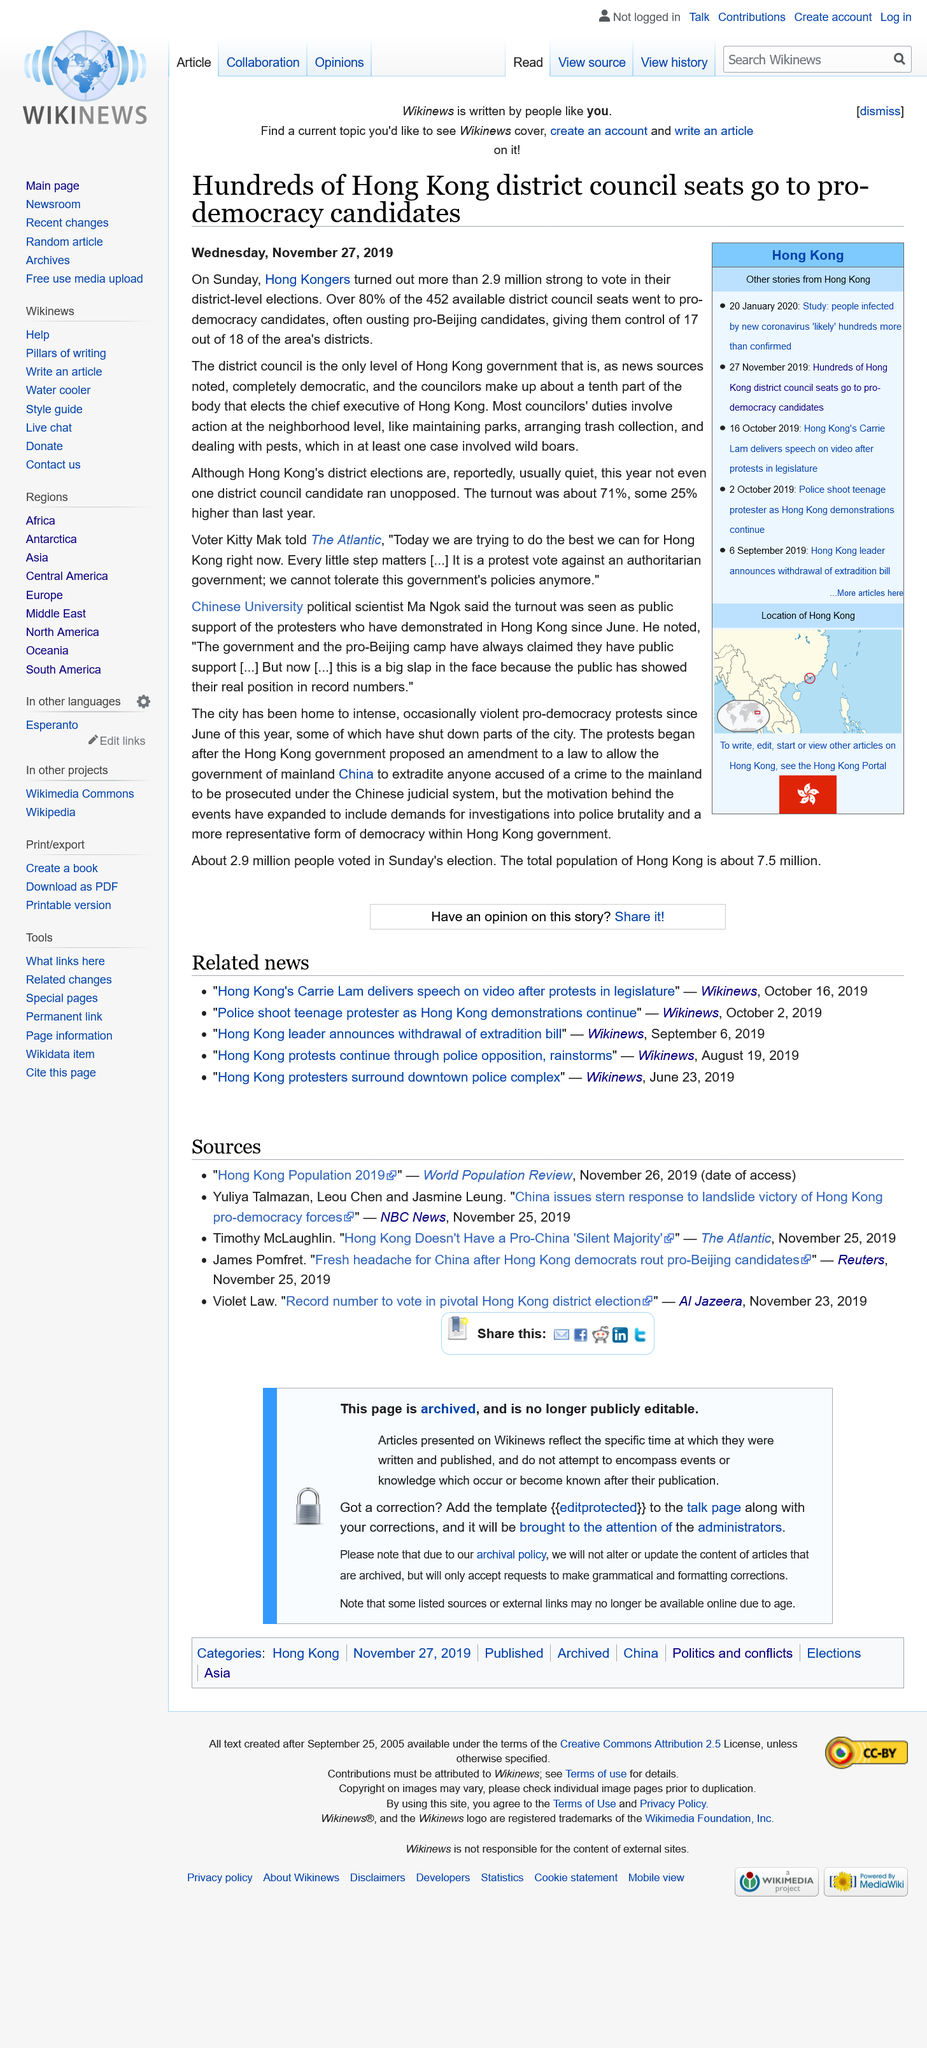Mention a couple of crucial points in this snapshot. The district elections in Hong Kong do not typically have 2.9 million voters. In fact, they are usually quite quiet. On Sunday, more than 2.9 million Hong Kongers turned out to vote in their district-level elections, demonstrating their strong commitment to democracy and self-governance. On January 20, 2020, a study was conducted on individuals affected by the new coronavirus. 